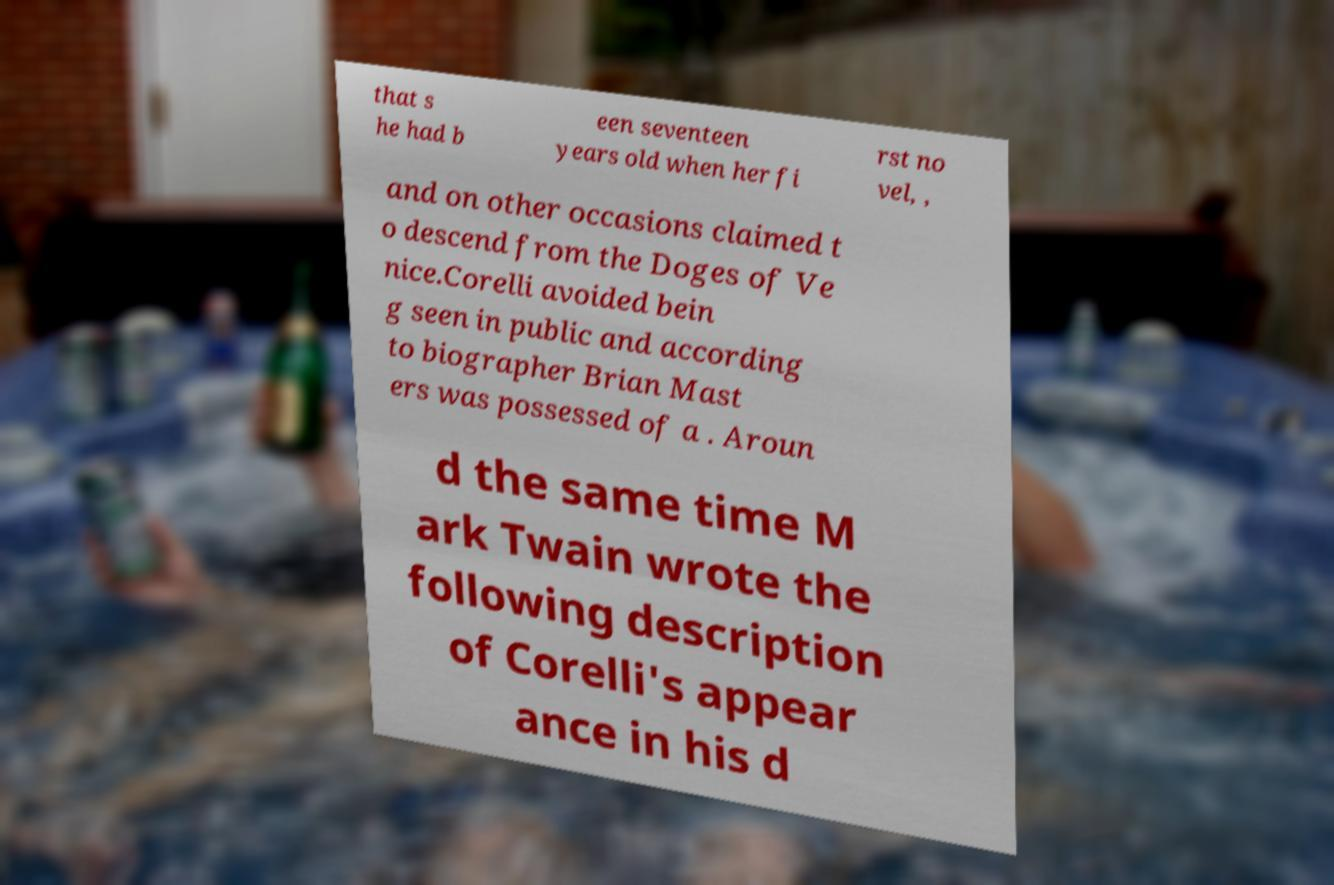Please identify and transcribe the text found in this image. that s he had b een seventeen years old when her fi rst no vel, , and on other occasions claimed t o descend from the Doges of Ve nice.Corelli avoided bein g seen in public and according to biographer Brian Mast ers was possessed of a . Aroun d the same time M ark Twain wrote the following description of Corelli's appear ance in his d 